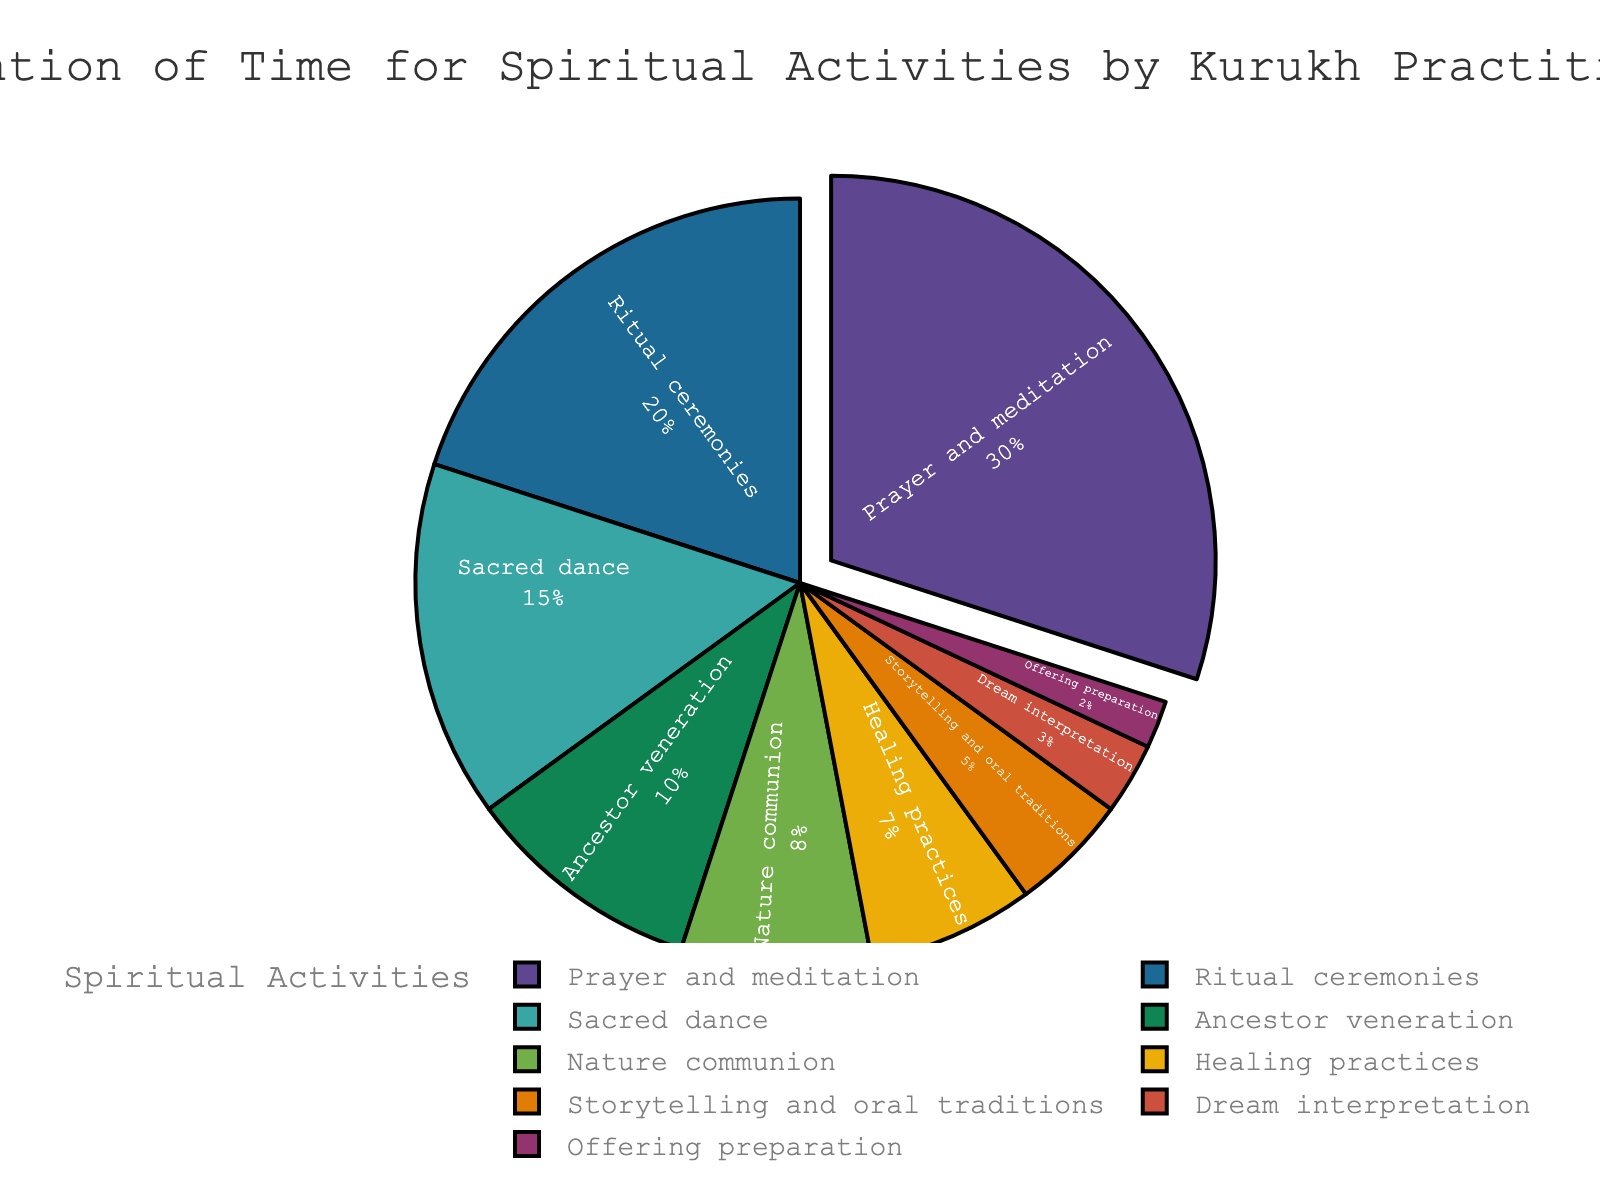what activity takes up the largest portion of the time? The largest portion of the pie chart is marked for "Prayer and meditation." Therefore, we can conclude that this activity takes up the largest portion of the time.
Answer: Prayer and meditation Which two activities together account for 50% of the time? The activities "Prayer and meditation" (30%) and "Ritual ceremonies" (20%) together sum to 30% + 20% = 50% of the total time allocation.
Answer: Prayer and meditation and Ritual ceremonies What is the difference in the percentage of time allocated to Sacred dance and Dream interpretation? The percentage of time for Sacred dance is 15%, and for Dream interpretation, it is 3%. The difference is calculated as 15% - 3% = 12%.
Answer: 12% If you combine the time spent on Nature communion, Healing practices, Storytelling and oral traditions, Dream interpretation, and Offering preparation, what is the total percentage? The respective percentages are 8%, 7%, 5%, 3%, and 2%. Adding them up: 8% + 7% + 5% + 3% + 2% = 25%.
Answer: 25% Which activity is shown using the second largest segment in the pie chart? The second largest segment is marked for "Ritual ceremonies," as it takes up 20% of the time, which is second only to "Prayer and meditation" at 30%.
Answer: Ritual ceremonies How many activities have a percentage of 10% or more? The activities with 10% or more are "Prayer and meditation" (30%), "Ritual ceremonies" (20%), and "Sacred dance" (15%), and "Ancestor veneration" (10%). Therefore, there are four such activities.
Answer: Four What color is used for representing the activity with the smallest time allocation? The smallest time allocation of 2% is for "Offering preparation." By looking at the pie chart, we can identify the color used for this segment.
Answer: Color used in the chart (visual answer) What is the combined time allocation for Healing practices and Storytelling and oral traditions? The percentages are 7% for Healing practices and 5% for Storytelling and oral traditions. Summing them up, 7% + 5% = 12%.
Answer: 12% Which two activities have the smallest percentage difference in their time allocation? The activities "Nature communion" and "Healing practices" have the percentages 8% and 7% respectively. The difference is 8% - 7% = 1%, which is the smallest difference among all pairs.
Answer: Nature communion and Healing practices 